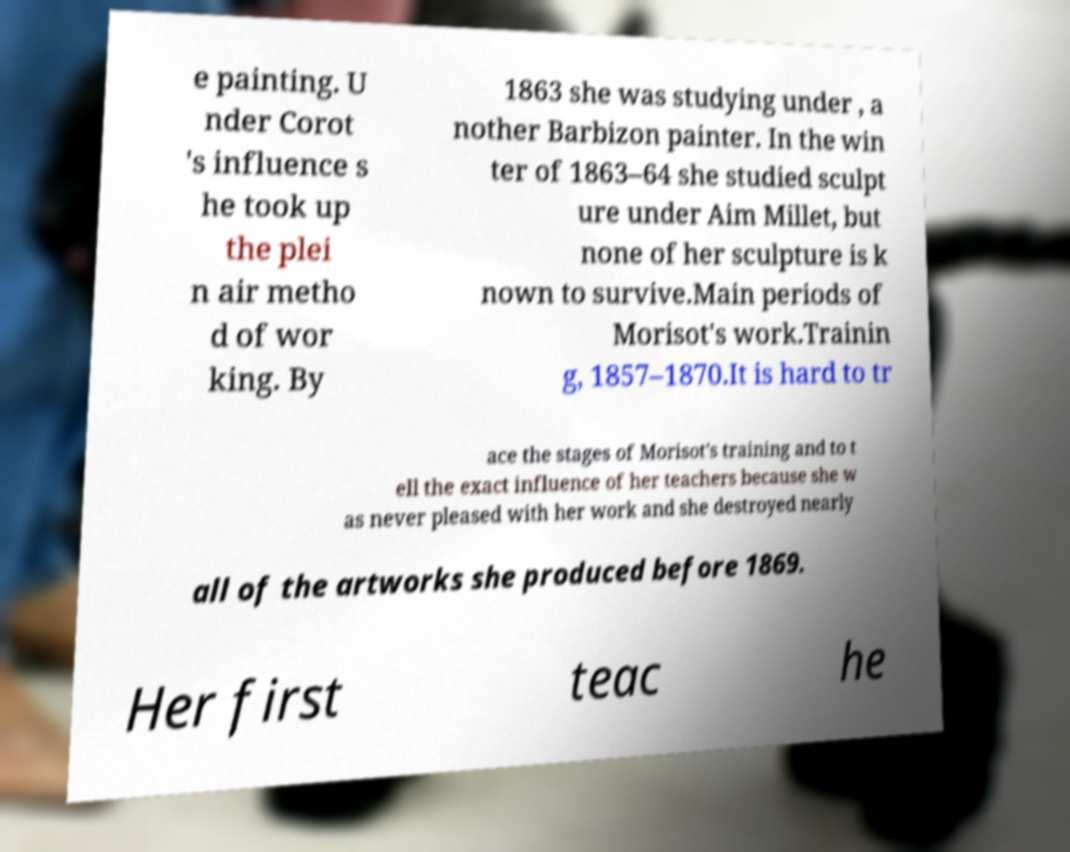Can you read and provide the text displayed in the image?This photo seems to have some interesting text. Can you extract and type it out for me? e painting. U nder Corot 's influence s he took up the plei n air metho d of wor king. By 1863 she was studying under , a nother Barbizon painter. In the win ter of 1863–64 she studied sculpt ure under Aim Millet, but none of her sculpture is k nown to survive.Main periods of Morisot's work.Trainin g, 1857–1870.It is hard to tr ace the stages of Morisot's training and to t ell the exact influence of her teachers because she w as never pleased with her work and she destroyed nearly all of the artworks she produced before 1869. Her first teac he 